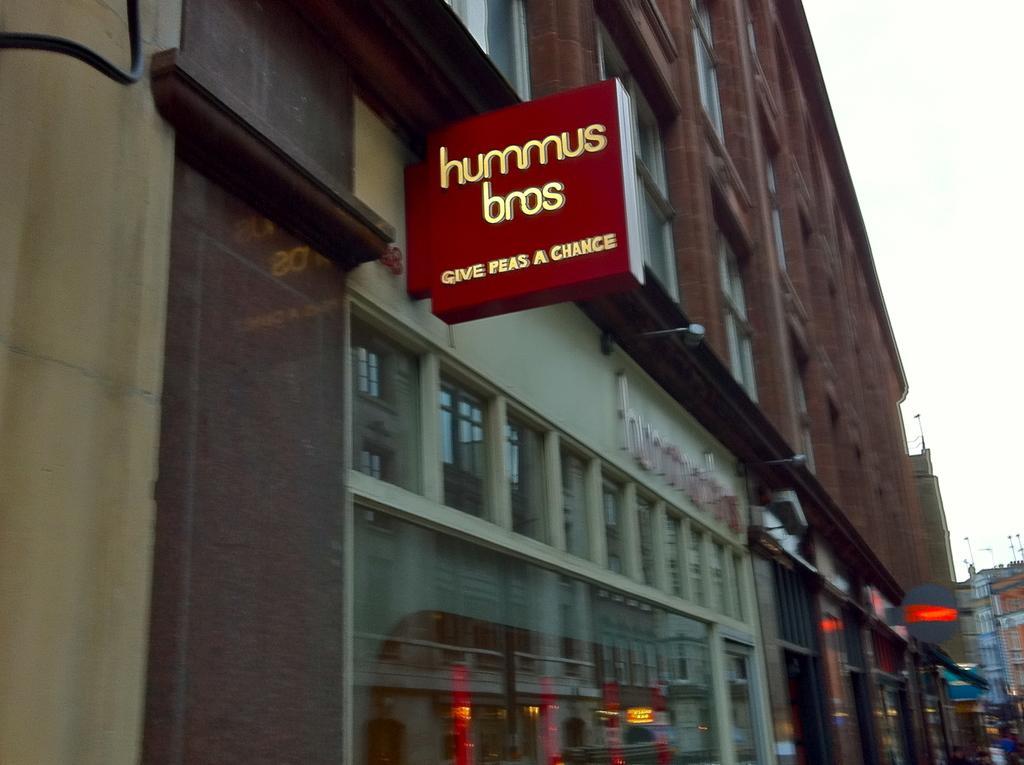How would you summarize this image in a sentence or two? In this image we can see buildings with glass windows and one board is attached to the building. 